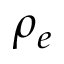<formula> <loc_0><loc_0><loc_500><loc_500>\rho _ { e }</formula> 